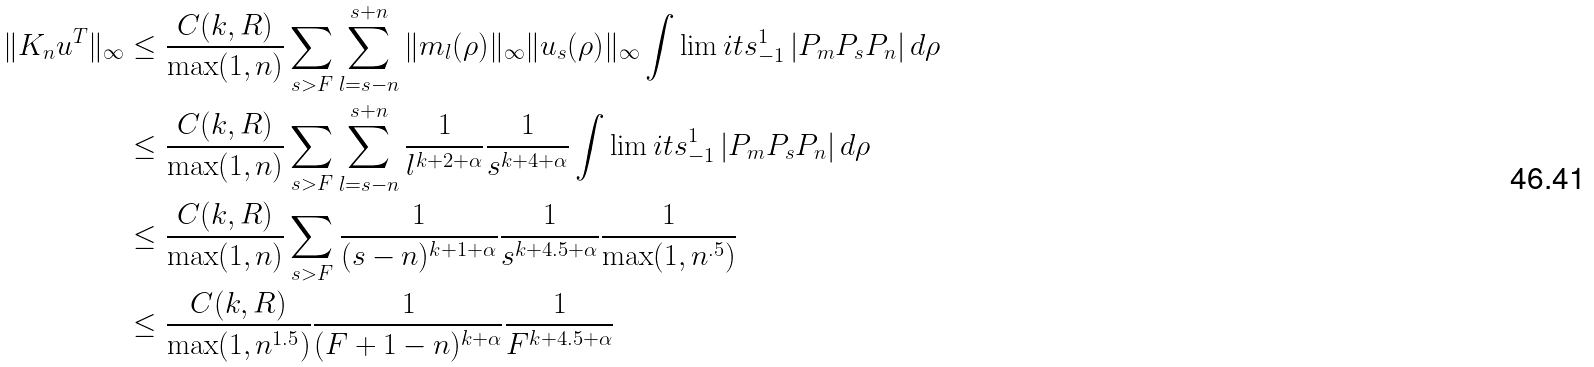Convert formula to latex. <formula><loc_0><loc_0><loc_500><loc_500>\| K _ { n } u ^ { T } \| _ { \infty } & \leq \frac { C ( k , R ) } { \max ( 1 , n ) } \sum _ { s > F } \sum _ { l = s - n } ^ { s + n } \| m _ { l } ( \rho ) \| _ { \infty } \| u _ { s } ( \rho ) \| _ { \infty } \int \lim i t s _ { - 1 } ^ { 1 } \, | P _ { m } P _ { s } P _ { n } | \, d \rho \\ & \leq \frac { C ( k , R ) } { \max ( 1 , n ) } \sum _ { s > F } \sum _ { l = s - n } ^ { s + n } \frac { 1 } { l ^ { k + 2 + \alpha } } \frac { 1 } { s ^ { k + 4 + \alpha } } \int \lim i t s _ { - 1 } ^ { 1 } \, | P _ { m } P _ { s } P _ { n } | \, d \rho \\ & \leq \frac { C ( k , R ) } { \max ( 1 , n ) } \sum _ { s > F } \frac { 1 } { ( s - n ) ^ { k + 1 + \alpha } } \frac { 1 } { s ^ { k + 4 . 5 + \alpha } } \frac { 1 } { \max ( 1 , n ^ { . 5 } ) } \\ & \leq \frac { C ( k , R ) } { \max ( 1 , n ^ { 1 . 5 } ) } \frac { 1 } { ( F + 1 - n ) ^ { k + \alpha } } \frac { 1 } { F ^ { k + 4 . 5 + \alpha } } \\</formula> 